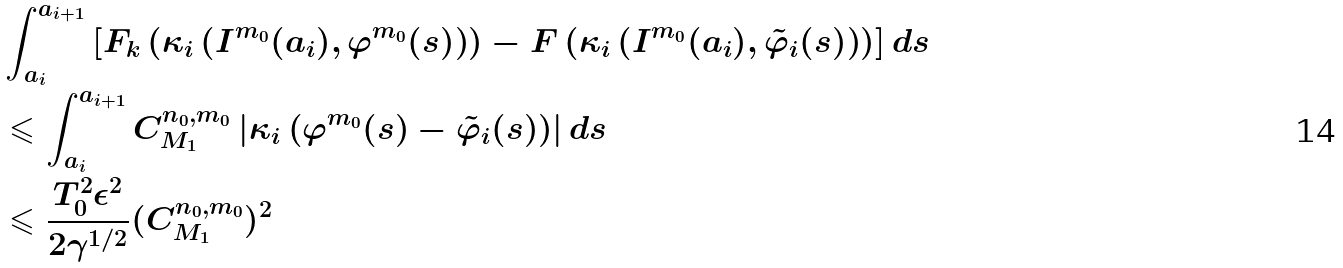Convert formula to latex. <formula><loc_0><loc_0><loc_500><loc_500>& \int _ { a _ { i } } ^ { a _ { i + 1 } } \left [ F _ { k } \left ( \kappa _ { i } \left ( I ^ { m _ { 0 } } ( a _ { i } ) , \varphi ^ { m _ { 0 } } ( s ) \right ) \right ) - F \left ( \kappa _ { i } \left ( I ^ { m _ { 0 } } ( a _ { i } ) , \tilde { \varphi } _ { i } ( s ) \right ) \right ) \right ] d s \\ & \leqslant \int _ { a _ { i } } ^ { a _ { i + 1 } } C _ { M _ { 1 } } ^ { n _ { 0 } , m _ { 0 } } \left | \kappa _ { i } \left ( \varphi ^ { m _ { 0 } } ( s ) - \tilde { \varphi } _ { i } ( s ) \right ) \right | d s \\ & \leqslant \frac { T _ { 0 } ^ { 2 } \epsilon ^ { 2 } } { 2 \gamma ^ { 1 / 2 } } ( C _ { M _ { 1 } } ^ { n _ { 0 } , m _ { 0 } } ) ^ { 2 }</formula> 